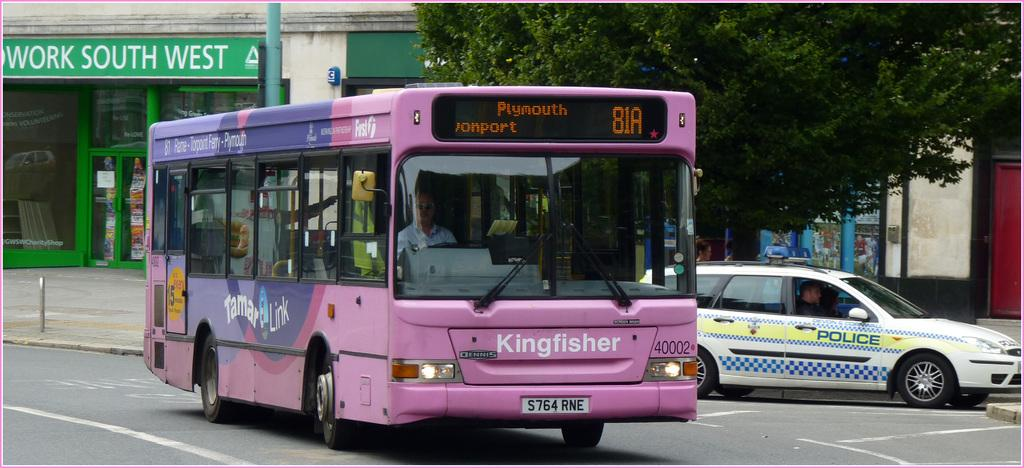<image>
Offer a succinct explanation of the picture presented. the word kingfisher on the front of a bus 